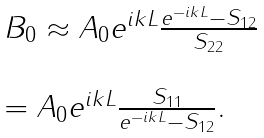Convert formula to latex. <formula><loc_0><loc_0><loc_500><loc_500>\begin{array} { l } B _ { 0 } \approx A _ { 0 } e ^ { i k L } \frac { e ^ { - i k L } - S _ { 1 2 } } { S _ { 2 2 } } \\ \ \\ = A _ { 0 } e ^ { i k L } \frac { S _ { 1 1 } } { e ^ { - i k L } - S _ { 1 2 } } . \\ \end{array}</formula> 